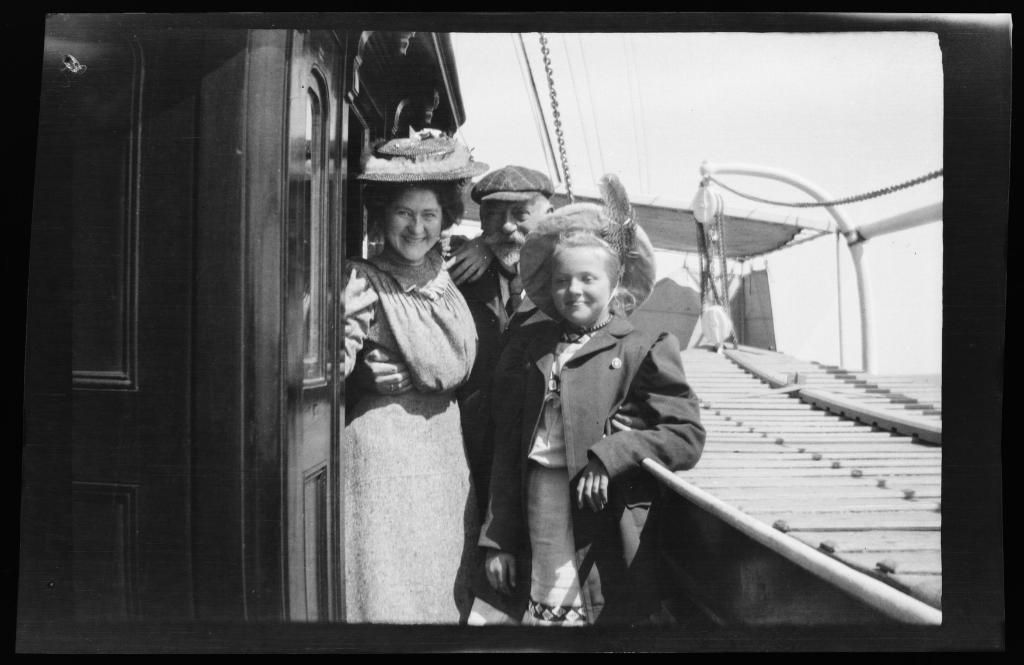What is the color scheme of the image? The image is black and white. How many people are in the image? There are three persons in the image. Where are the persons located in the image? The persons are standing on a ship. What type of flesh can be seen on the ship in the image? There is no flesh visible in the image, as it is a black and white photograph of three people standing on a ship. 